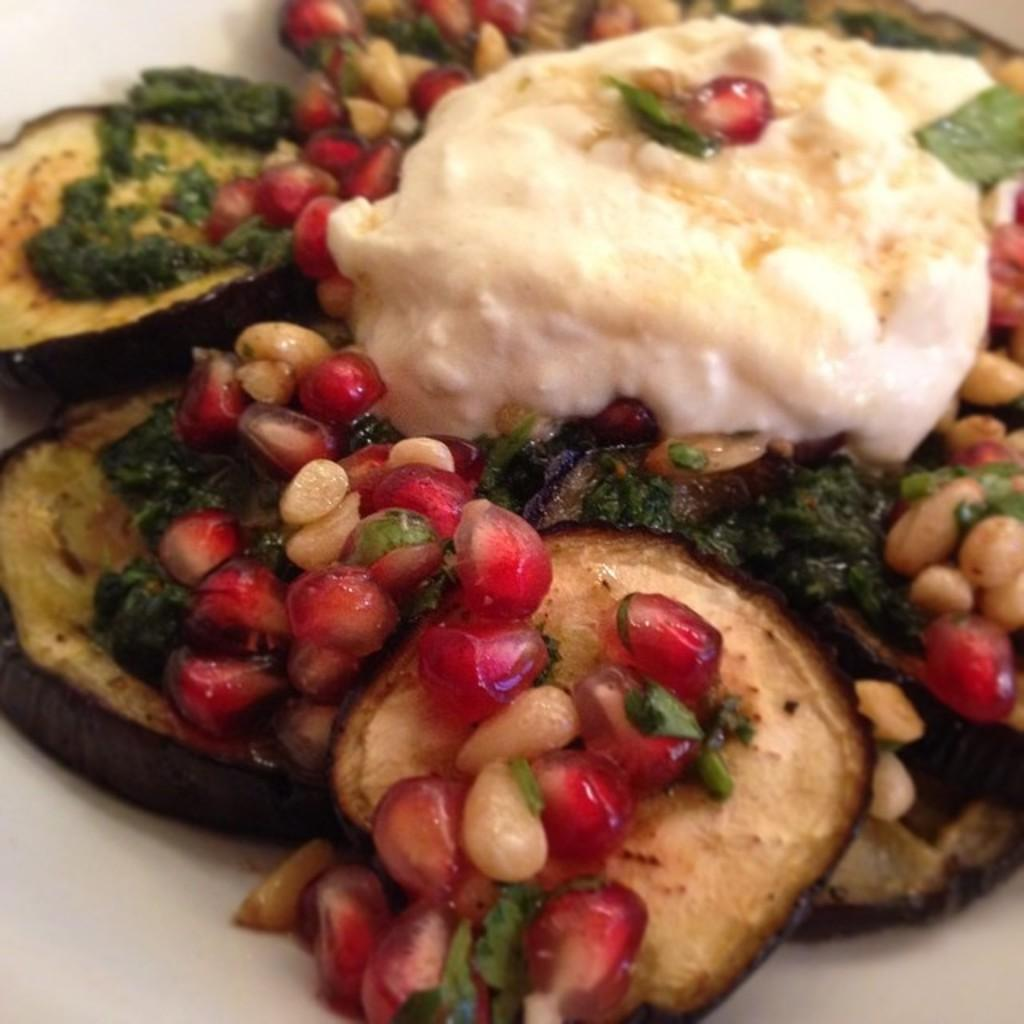What type of cooked food item can be seen in the image? There is a cooked food item in the image. How is the food item decorated or garnished? The food item is garnished with pomegranates and cream. What type of sand can be seen covering the sock in the image? There is no sock or sand present in the image; it features a cooked food item garnished with pomegranates and cream. 